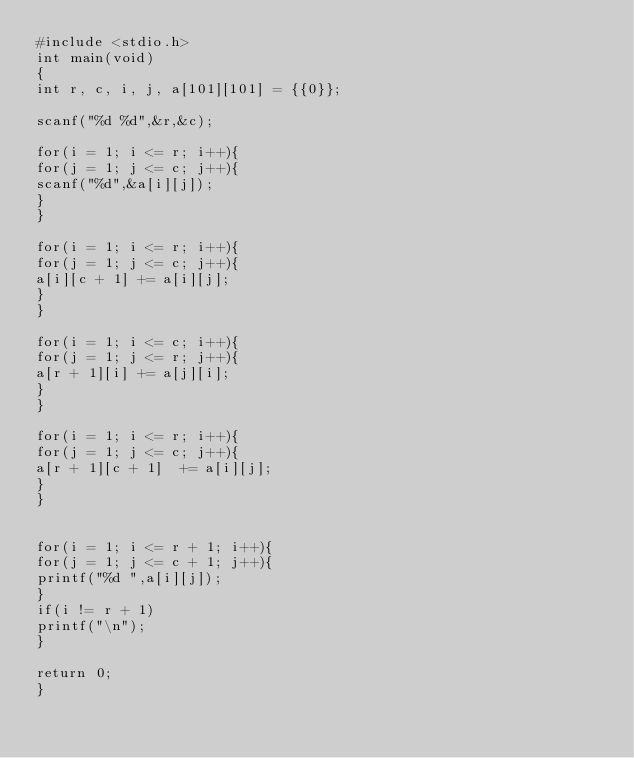Convert code to text. <code><loc_0><loc_0><loc_500><loc_500><_C_>#include <stdio.h>
int main(void)
{
int r, c, i, j, a[101][101] = {{0}};

scanf("%d %d",&r,&c);

for(i = 1; i <= r; i++){
for(j = 1; j <= c; j++){
scanf("%d",&a[i][j]);
}
}

for(i = 1; i <= r; i++){
for(j = 1; j <= c; j++){
a[i][c + 1] += a[i][j];
}
}

for(i = 1; i <= c; i++){
for(j = 1; j <= r; j++){
a[r + 1][i] += a[j][i];
}
}

for(i = 1; i <= r; i++){
for(j = 1; j <= c; j++){
a[r + 1][c + 1]  += a[i][j];
}
}


for(i = 1; i <= r + 1; i++){
for(j = 1; j <= c + 1; j++){
printf("%d ",a[i][j]);
}
if(i != r + 1)
printf("\n");
}

return 0;
}</code> 